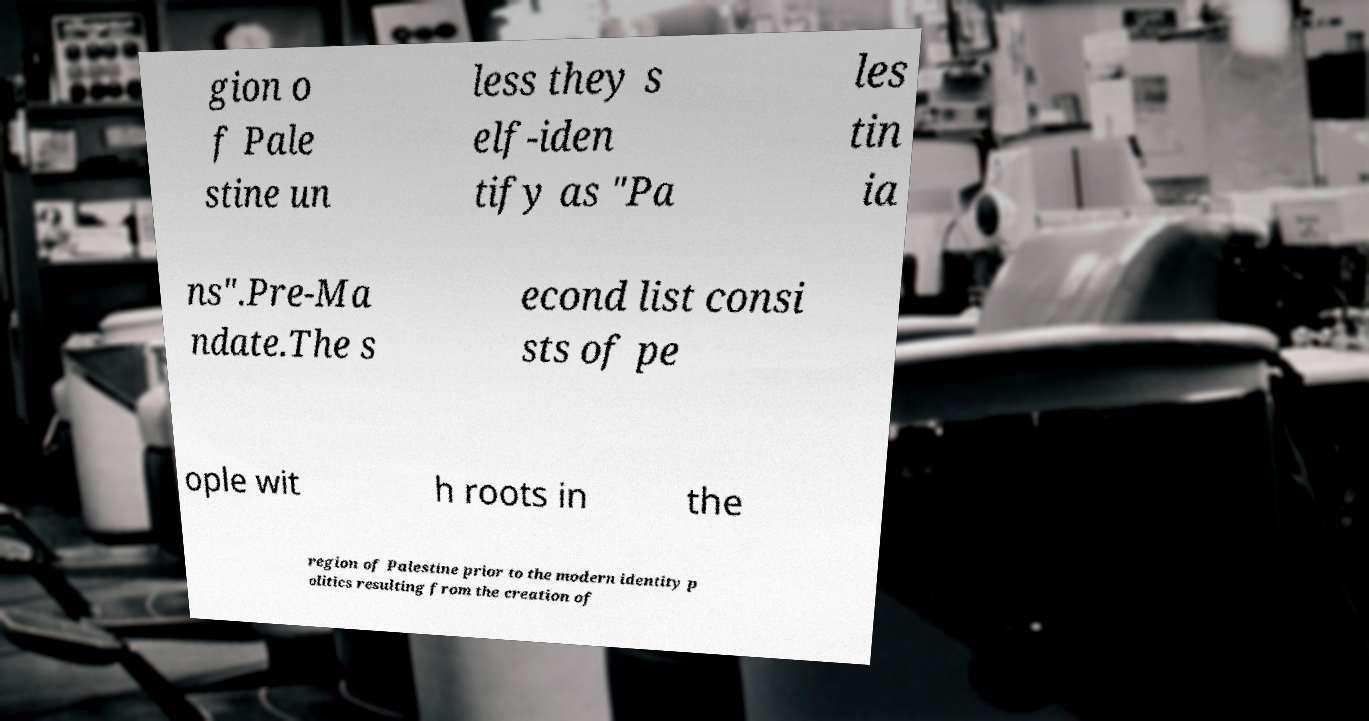Please read and relay the text visible in this image. What does it say? gion o f Pale stine un less they s elf-iden tify as "Pa les tin ia ns".Pre-Ma ndate.The s econd list consi sts of pe ople wit h roots in the region of Palestine prior to the modern identity p olitics resulting from the creation of 